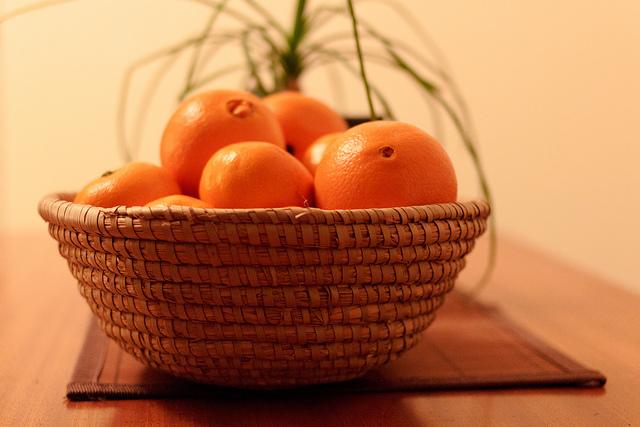What is that thing in the background?
Give a very brief answer. Plant. What kind of basket is it?
Quick response, please. Wicker. What is in the basket?
Answer briefly. Oranges. 